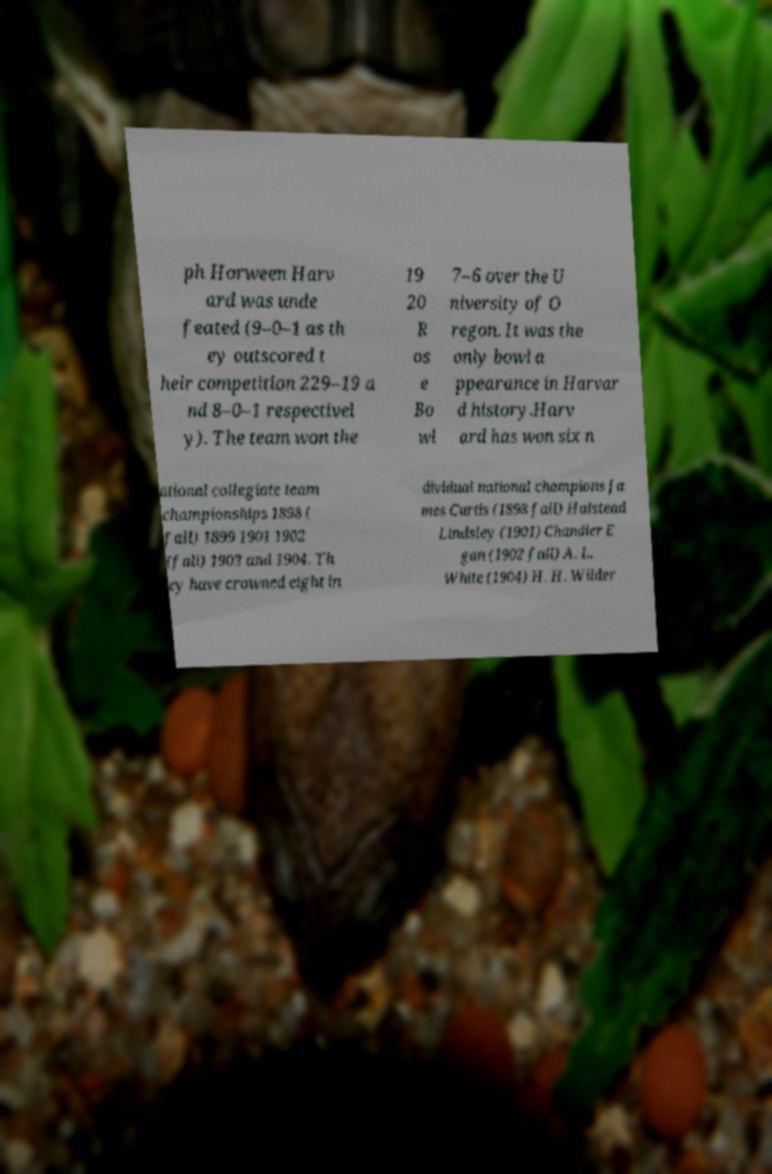Please identify and transcribe the text found in this image. ph Horween Harv ard was unde feated (9–0–1 as th ey outscored t heir competition 229–19 a nd 8–0–1 respectivel y). The team won the 19 20 R os e Bo wl 7–6 over the U niversity of O regon. It was the only bowl a ppearance in Harvar d history.Harv ard has won six n ational collegiate team championships 1898 ( fall) 1899 1901 1902 (fall) 1903 and 1904. Th ey have crowned eight in dividual national champions Ja mes Curtis (1898 fall) Halstead Lindsley (1901) Chandler E gan (1902 fall) A. L. White (1904) H. H. Wilder 